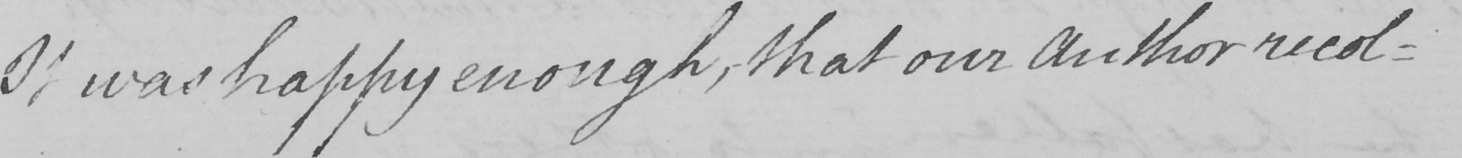Please transcribe the handwritten text in this image. It was happy enough , that our Author recol= 